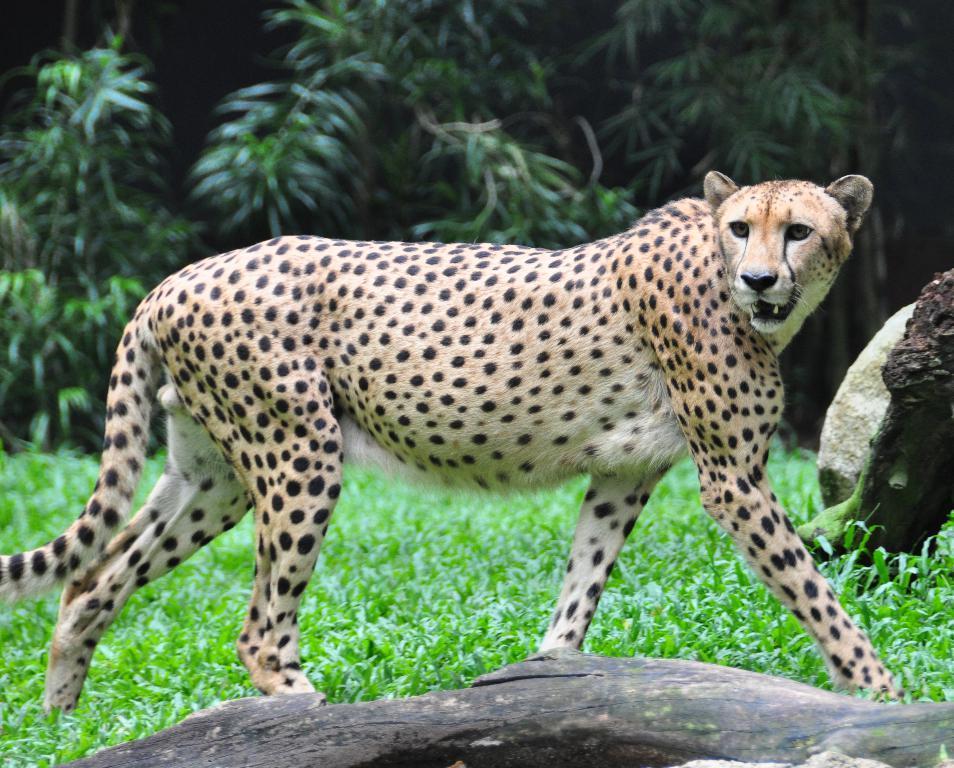Could you give a brief overview of what you see in this image? In this image I can see an open grass ground and on it I can see a tree trunk and a cheetah is standing in the front. In the background I can see number of trees and on the right side of this image I can see a stone. 